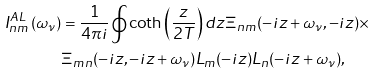<formula> <loc_0><loc_0><loc_500><loc_500>I _ { n m } ^ { A L } \left ( \omega _ { \nu } \right ) & = \frac { 1 } { 4 \pi i } \oint \coth \left ( \frac { z } { 2 T } \right ) d z \Xi _ { n m } ( - i z + \omega _ { \nu } , - i z ) \times \\ & \Xi _ { m n } ( - i z , - i z + \omega _ { \nu } ) L _ { m } ( - i z ) L _ { n } ( - i z + \omega _ { \nu } ) ,</formula> 